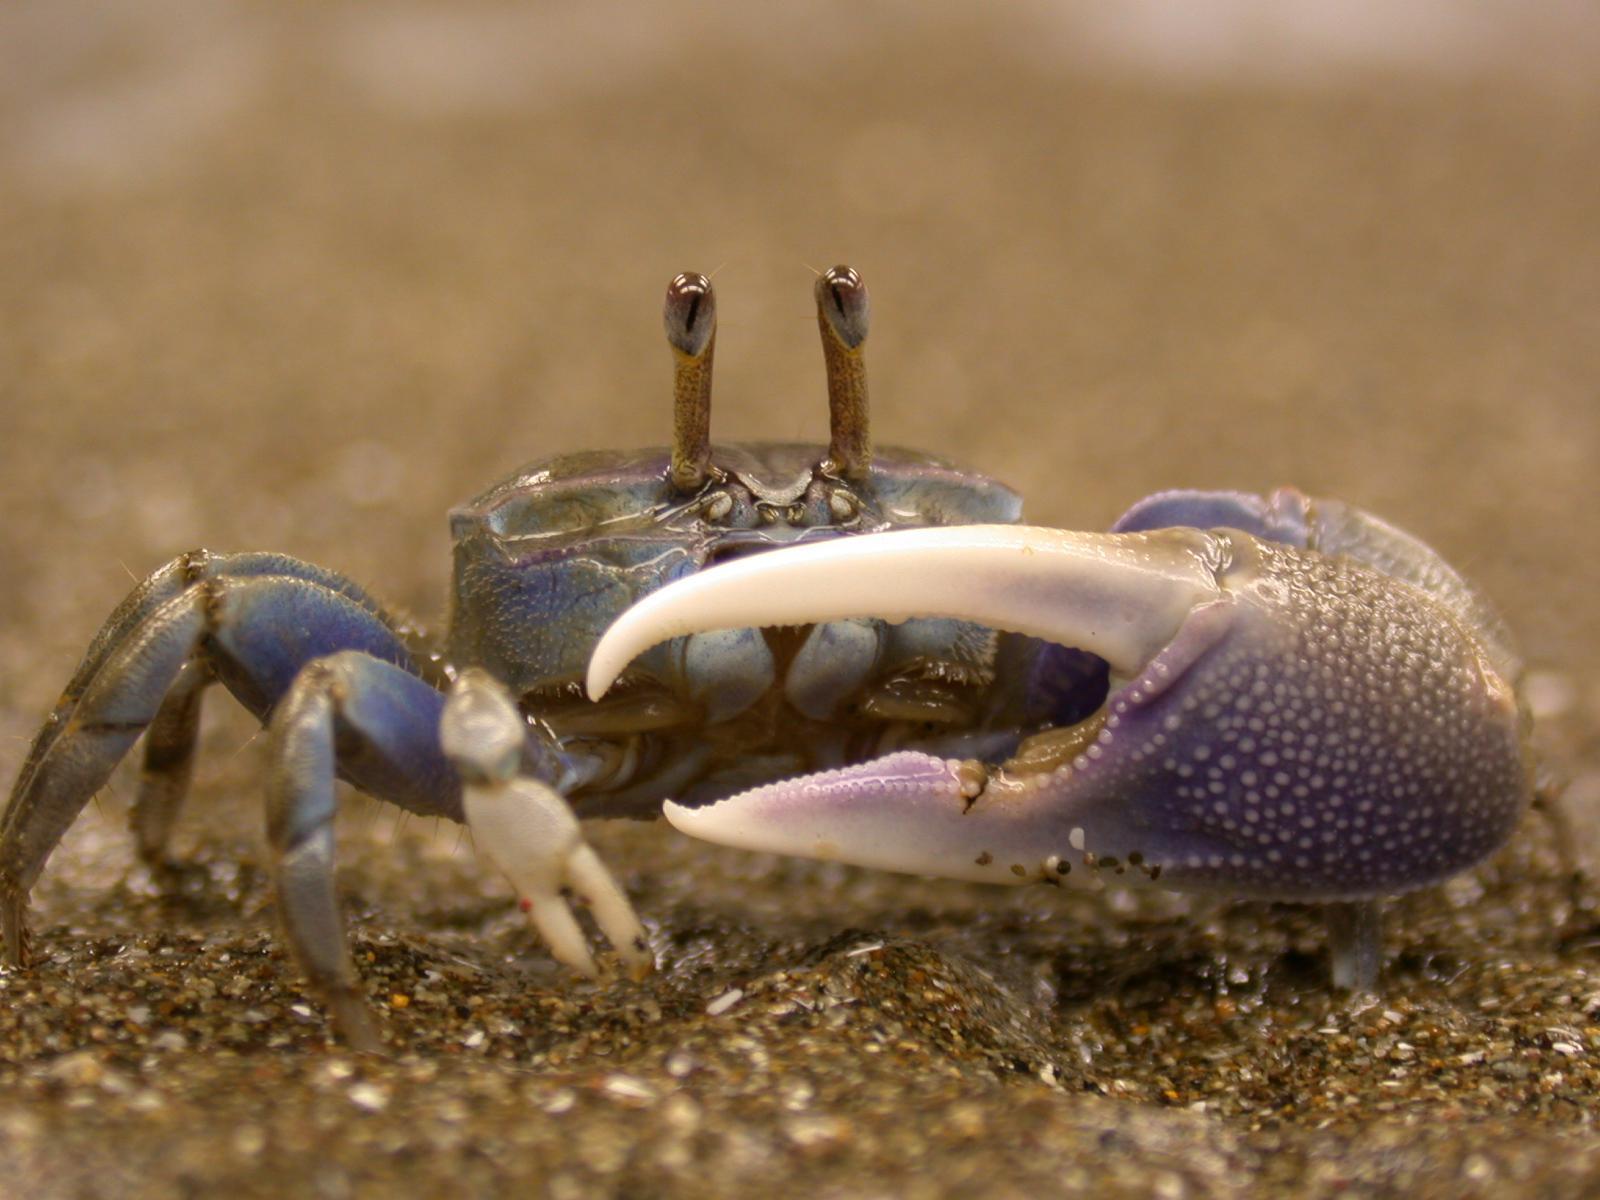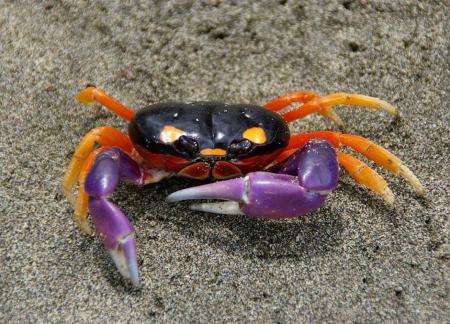The first image is the image on the left, the second image is the image on the right. Examine the images to the left and right. Is the description "The crab in each of the images is positioned on a sandy sediment." accurate? Answer yes or no. Yes. The first image is the image on the left, the second image is the image on the right. Analyze the images presented: Is the assertion "Exactly one crab's left claw is higher than its right." valid? Answer yes or no. No. 